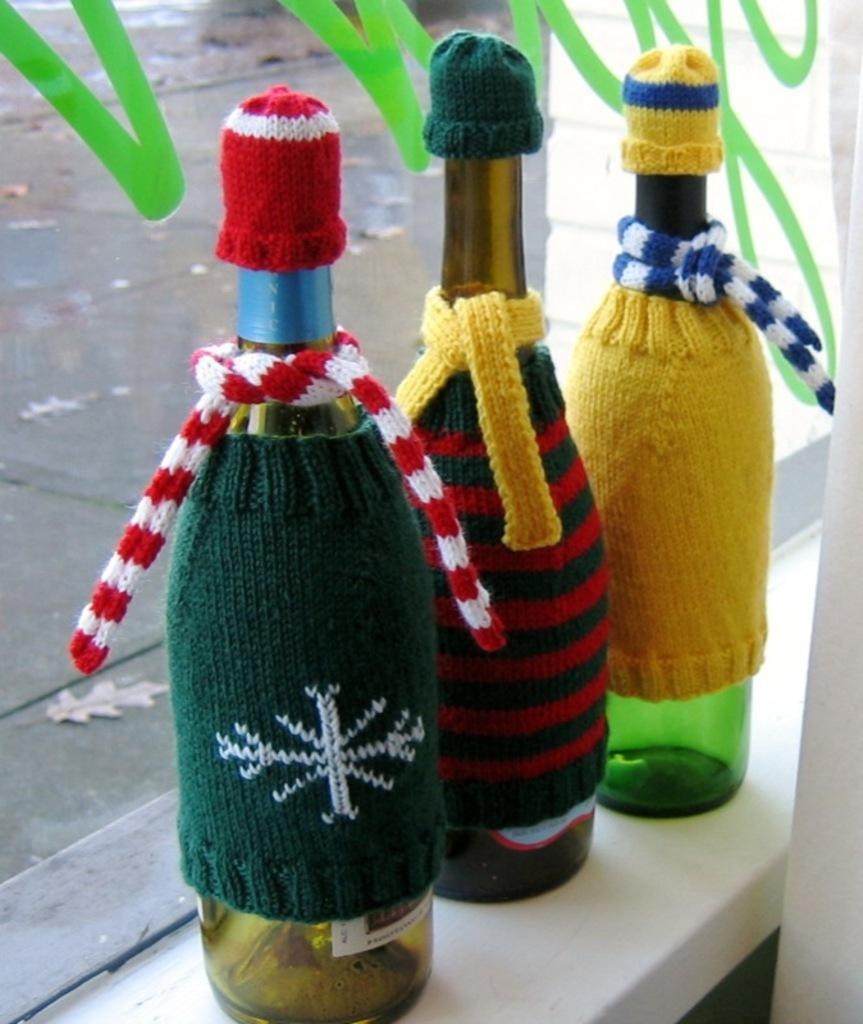How many bottles are visible in the image? There are three bottles in the image. Where are the bottles located? The bottles are on a table. What is covering the bottles in the image? The bottles have wool covering their bodies. What is the purpose of the wool on the bottles? The wool serves as a scarf and a cap for the bottles. Can you see any fairies interacting with the bottles in the image? There are no fairies present in the image. 